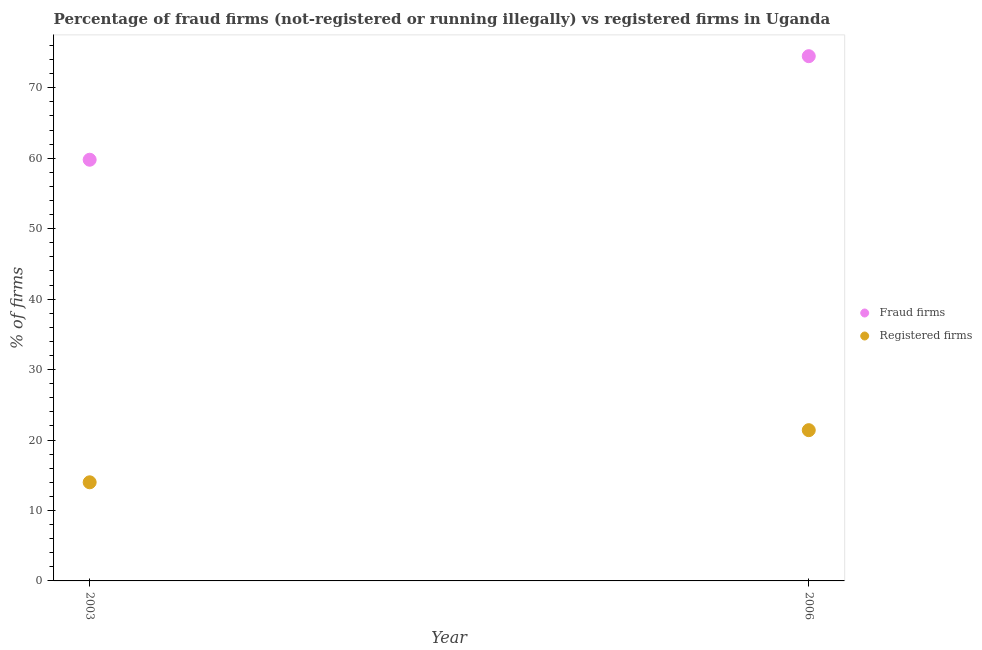How many different coloured dotlines are there?
Your answer should be very brief. 2. Is the number of dotlines equal to the number of legend labels?
Keep it short and to the point. Yes. Across all years, what is the maximum percentage of fraud firms?
Offer a very short reply. 74.49. Across all years, what is the minimum percentage of fraud firms?
Offer a terse response. 59.79. In which year was the percentage of fraud firms maximum?
Your answer should be compact. 2006. What is the total percentage of fraud firms in the graph?
Offer a very short reply. 134.28. What is the difference between the percentage of fraud firms in 2003 and that in 2006?
Give a very brief answer. -14.7. What is the difference between the percentage of fraud firms in 2003 and the percentage of registered firms in 2006?
Keep it short and to the point. 38.39. What is the average percentage of fraud firms per year?
Ensure brevity in your answer.  67.14. In the year 2003, what is the difference between the percentage of fraud firms and percentage of registered firms?
Provide a succinct answer. 45.79. In how many years, is the percentage of fraud firms greater than 34 %?
Your answer should be very brief. 2. What is the ratio of the percentage of fraud firms in 2003 to that in 2006?
Offer a terse response. 0.8. Is the percentage of registered firms strictly greater than the percentage of fraud firms over the years?
Your answer should be compact. No. Are the values on the major ticks of Y-axis written in scientific E-notation?
Your answer should be very brief. No. Does the graph contain grids?
Ensure brevity in your answer.  No. How many legend labels are there?
Keep it short and to the point. 2. How are the legend labels stacked?
Provide a short and direct response. Vertical. What is the title of the graph?
Your response must be concise. Percentage of fraud firms (not-registered or running illegally) vs registered firms in Uganda. Does "Infant" appear as one of the legend labels in the graph?
Ensure brevity in your answer.  No. What is the label or title of the X-axis?
Offer a terse response. Year. What is the label or title of the Y-axis?
Your answer should be compact. % of firms. What is the % of firms of Fraud firms in 2003?
Keep it short and to the point. 59.79. What is the % of firms in Registered firms in 2003?
Ensure brevity in your answer.  14. What is the % of firms in Fraud firms in 2006?
Ensure brevity in your answer.  74.49. What is the % of firms in Registered firms in 2006?
Make the answer very short. 21.4. Across all years, what is the maximum % of firms in Fraud firms?
Your answer should be compact. 74.49. Across all years, what is the maximum % of firms of Registered firms?
Make the answer very short. 21.4. Across all years, what is the minimum % of firms of Fraud firms?
Provide a short and direct response. 59.79. What is the total % of firms of Fraud firms in the graph?
Provide a short and direct response. 134.28. What is the total % of firms in Registered firms in the graph?
Make the answer very short. 35.4. What is the difference between the % of firms of Fraud firms in 2003 and that in 2006?
Make the answer very short. -14.7. What is the difference between the % of firms in Registered firms in 2003 and that in 2006?
Provide a short and direct response. -7.4. What is the difference between the % of firms of Fraud firms in 2003 and the % of firms of Registered firms in 2006?
Keep it short and to the point. 38.39. What is the average % of firms of Fraud firms per year?
Offer a very short reply. 67.14. What is the average % of firms in Registered firms per year?
Keep it short and to the point. 17.7. In the year 2003, what is the difference between the % of firms of Fraud firms and % of firms of Registered firms?
Make the answer very short. 45.79. In the year 2006, what is the difference between the % of firms of Fraud firms and % of firms of Registered firms?
Your answer should be compact. 53.09. What is the ratio of the % of firms in Fraud firms in 2003 to that in 2006?
Offer a very short reply. 0.8. What is the ratio of the % of firms of Registered firms in 2003 to that in 2006?
Offer a terse response. 0.65. What is the difference between the highest and the lowest % of firms of Fraud firms?
Give a very brief answer. 14.7. 